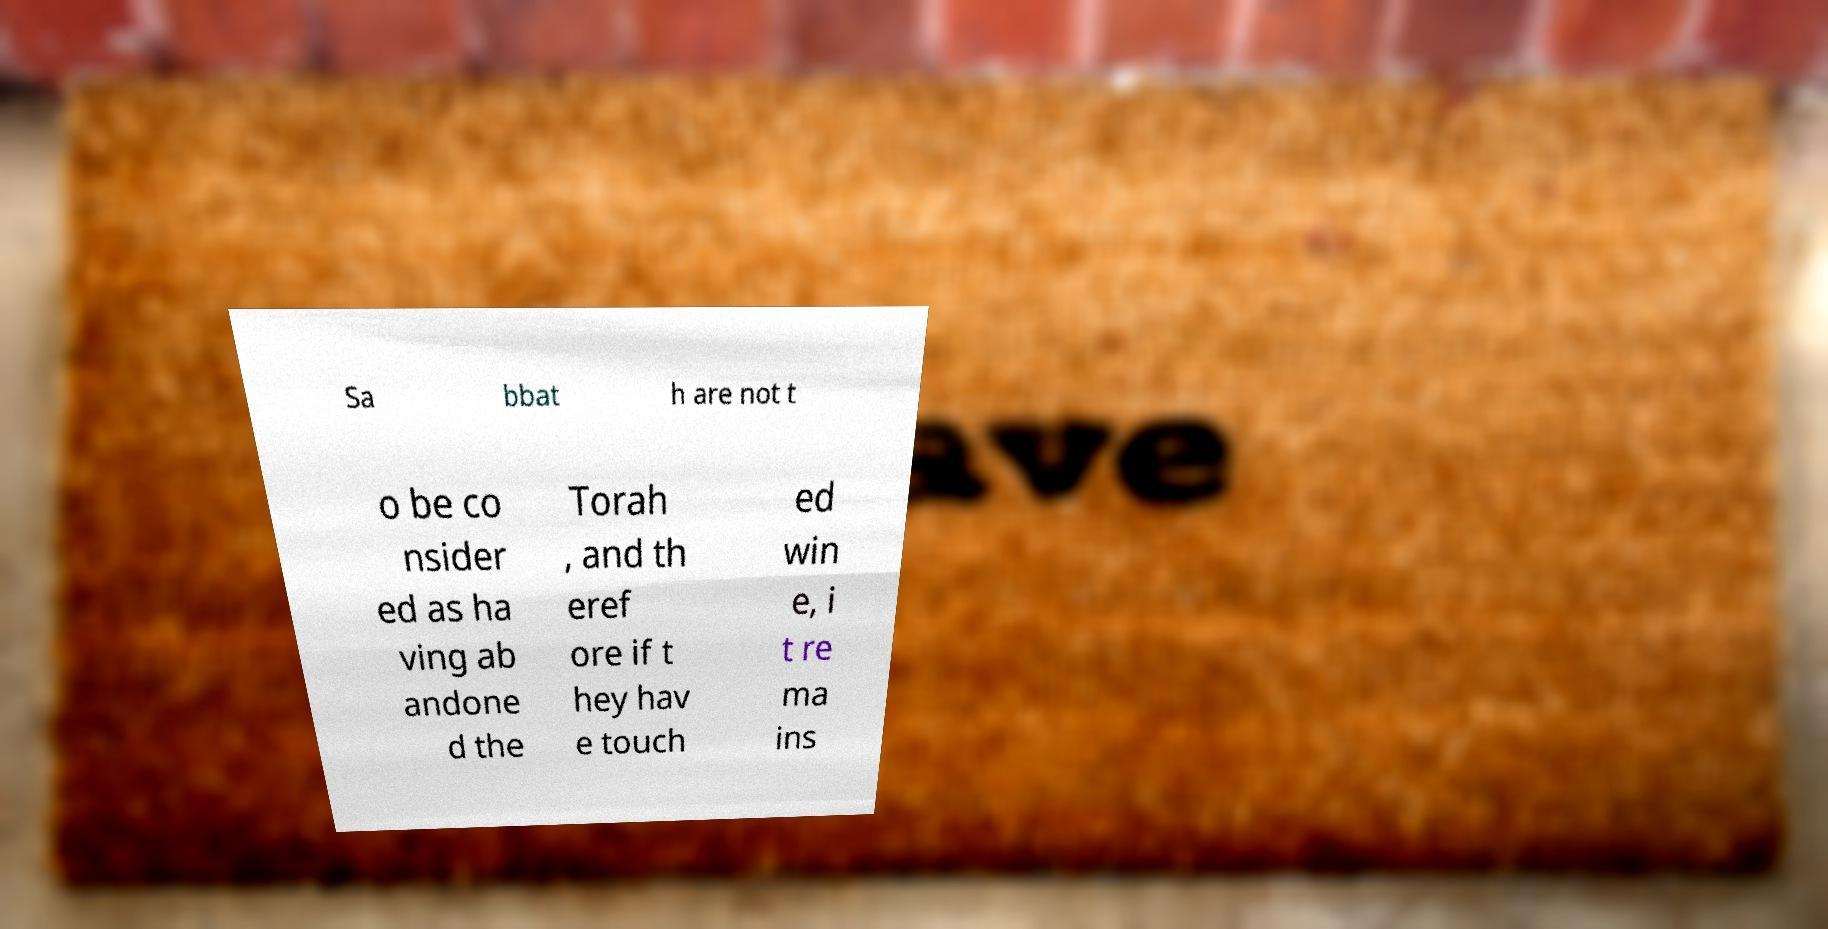Could you extract and type out the text from this image? Sa bbat h are not t o be co nsider ed as ha ving ab andone d the Torah , and th eref ore if t hey hav e touch ed win e, i t re ma ins 